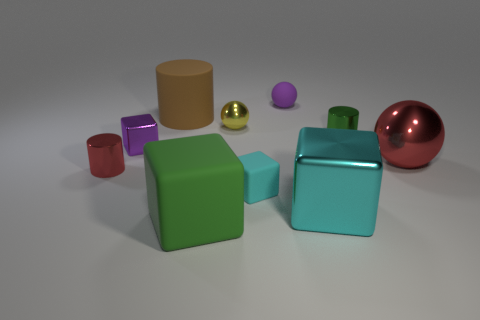Are there any blue rubber blocks of the same size as the yellow metallic object?
Your answer should be very brief. No. What is the material of the sphere that is the same size as the yellow object?
Your answer should be very brief. Rubber. Do the cyan metal thing and the red object on the left side of the purple ball have the same size?
Make the answer very short. No. There is a small thing that is to the right of the small purple rubber sphere; what is its material?
Offer a terse response. Metal. Is the number of small yellow metallic things that are on the right side of the tiny green shiny thing the same as the number of small red metallic cylinders?
Offer a terse response. No. Is the size of the cyan metal object the same as the red shiny cylinder?
Give a very brief answer. No. There is a tiny cylinder right of the small matte object behind the tiny green object; are there any purple balls on the right side of it?
Provide a short and direct response. No. What is the material of the red object that is the same shape as the small purple rubber object?
Ensure brevity in your answer.  Metal. There is a rubber thing that is left of the big green object; what number of cylinders are in front of it?
Provide a short and direct response. 2. There is a cyan cube to the right of the tiny rubber sphere that is behind the rubber thing to the left of the large green rubber object; how big is it?
Your answer should be compact. Large. 